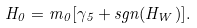<formula> <loc_0><loc_0><loc_500><loc_500>H _ { 0 } = m _ { 0 } [ \gamma _ { 5 } + s g n ( H _ { W } ) ] .</formula> 